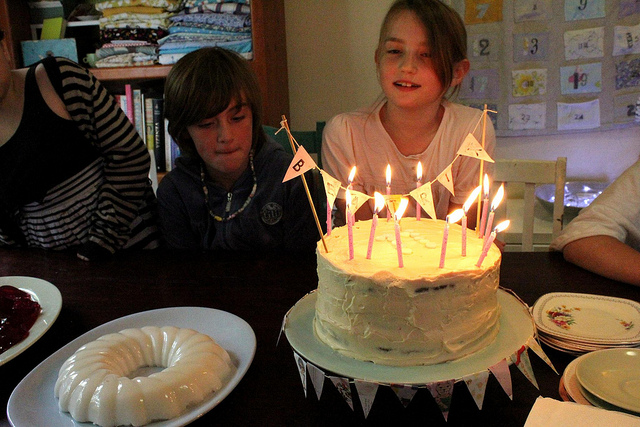Identify the text displayed in this image. 7 2 3 19 24 